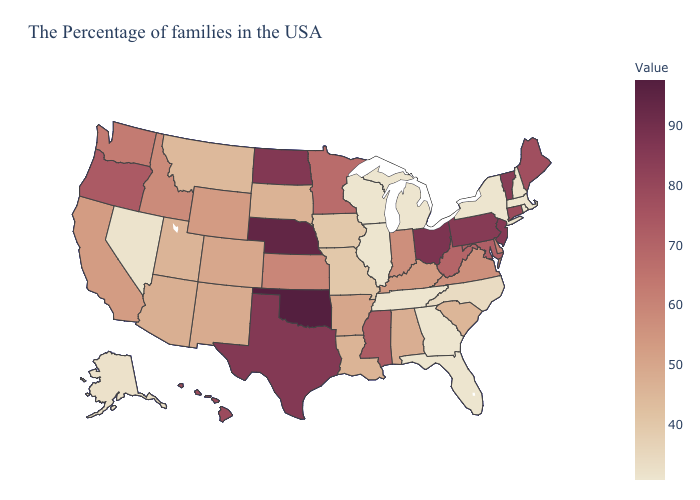Does Illinois have the lowest value in the USA?
Short answer required. Yes. Which states have the lowest value in the USA?
Write a very short answer. Massachusetts, Rhode Island, New York, Florida, Georgia, Michigan, Tennessee, Wisconsin, Illinois. Among the states that border North Carolina , does Virginia have the highest value?
Be succinct. Yes. Does Minnesota have the lowest value in the MidWest?
Quick response, please. No. Does Maryland have the lowest value in the South?
Quick response, please. No. 